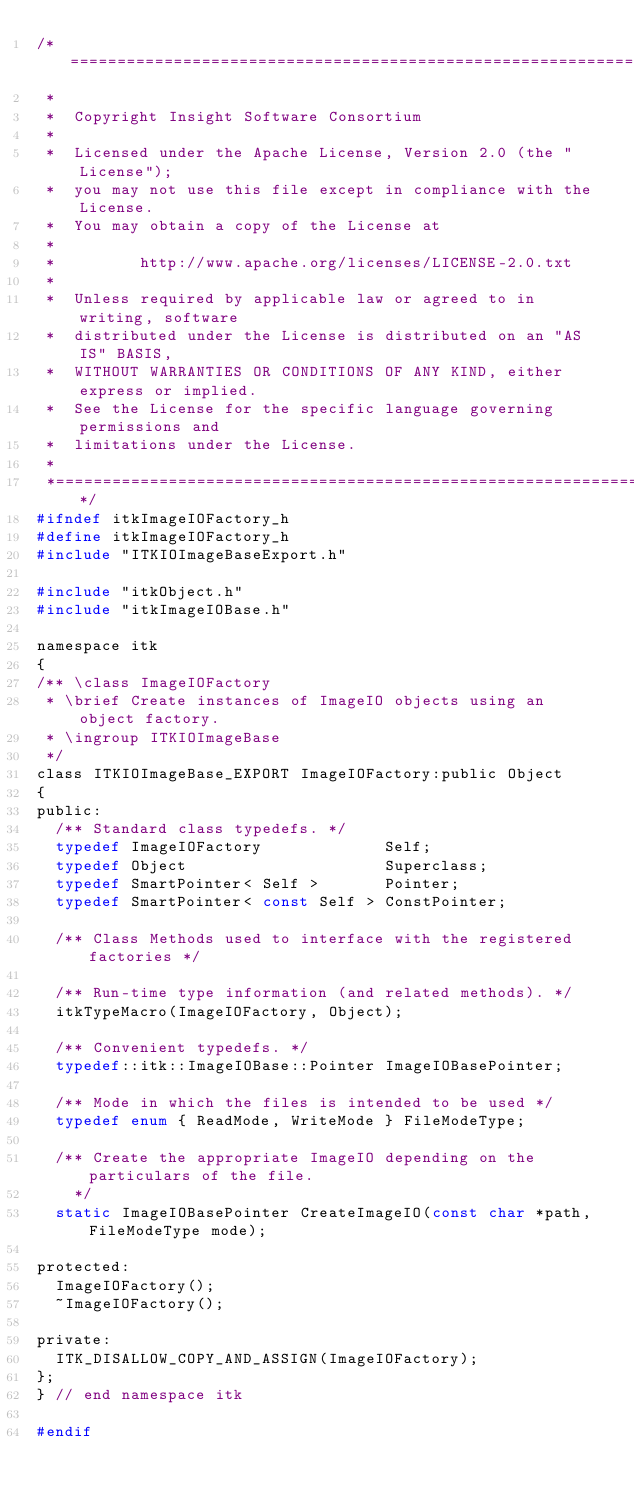<code> <loc_0><loc_0><loc_500><loc_500><_C_>/*=========================================================================
 *
 *  Copyright Insight Software Consortium
 *
 *  Licensed under the Apache License, Version 2.0 (the "License");
 *  you may not use this file except in compliance with the License.
 *  You may obtain a copy of the License at
 *
 *         http://www.apache.org/licenses/LICENSE-2.0.txt
 *
 *  Unless required by applicable law or agreed to in writing, software
 *  distributed under the License is distributed on an "AS IS" BASIS,
 *  WITHOUT WARRANTIES OR CONDITIONS OF ANY KIND, either express or implied.
 *  See the License for the specific language governing permissions and
 *  limitations under the License.
 *
 *=========================================================================*/
#ifndef itkImageIOFactory_h
#define itkImageIOFactory_h
#include "ITKIOImageBaseExport.h"

#include "itkObject.h"
#include "itkImageIOBase.h"

namespace itk
{
/** \class ImageIOFactory
 * \brief Create instances of ImageIO objects using an object factory.
 * \ingroup ITKIOImageBase
 */
class ITKIOImageBase_EXPORT ImageIOFactory:public Object
{
public:
  /** Standard class typedefs. */
  typedef ImageIOFactory             Self;
  typedef Object                     Superclass;
  typedef SmartPointer< Self >       Pointer;
  typedef SmartPointer< const Self > ConstPointer;

  /** Class Methods used to interface with the registered factories */

  /** Run-time type information (and related methods). */
  itkTypeMacro(ImageIOFactory, Object);

  /** Convenient typedefs. */
  typedef::itk::ImageIOBase::Pointer ImageIOBasePointer;

  /** Mode in which the files is intended to be used */
  typedef enum { ReadMode, WriteMode } FileModeType;

  /** Create the appropriate ImageIO depending on the particulars of the file.
    */
  static ImageIOBasePointer CreateImageIO(const char *path, FileModeType mode);

protected:
  ImageIOFactory();
  ~ImageIOFactory();

private:
  ITK_DISALLOW_COPY_AND_ASSIGN(ImageIOFactory);
};
} // end namespace itk

#endif
</code> 